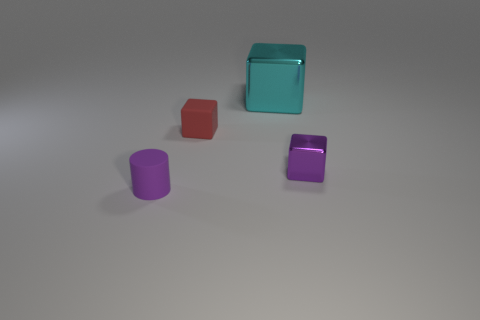There is a rubber cylinder that is the same color as the tiny shiny thing; what size is it?
Provide a succinct answer. Small. What number of tiny things are either red rubber blocks or shiny blocks?
Your response must be concise. 2. What number of tiny purple shiny blocks are there?
Your answer should be very brief. 1. Is the number of rubber cylinders that are on the right side of the cyan cube the same as the number of red objects that are on the right side of the tiny purple metallic block?
Give a very brief answer. Yes. There is a large cyan shiny cube; are there any small objects on the left side of it?
Give a very brief answer. Yes. What is the color of the metallic cube in front of the large cyan shiny cube?
Keep it short and to the point. Purple. What is the purple thing on the right side of the tiny purple thing that is on the left side of the tiny purple shiny block made of?
Offer a very short reply. Metal. Are there fewer rubber objects that are on the right side of the small red rubber cube than cyan shiny things that are in front of the small purple cube?
Your answer should be compact. No. What number of cyan objects are large matte things or cylinders?
Give a very brief answer. 0. Is the number of purple cylinders that are on the right side of the tiny matte cylinder the same as the number of small red rubber cubes?
Offer a very short reply. No. 